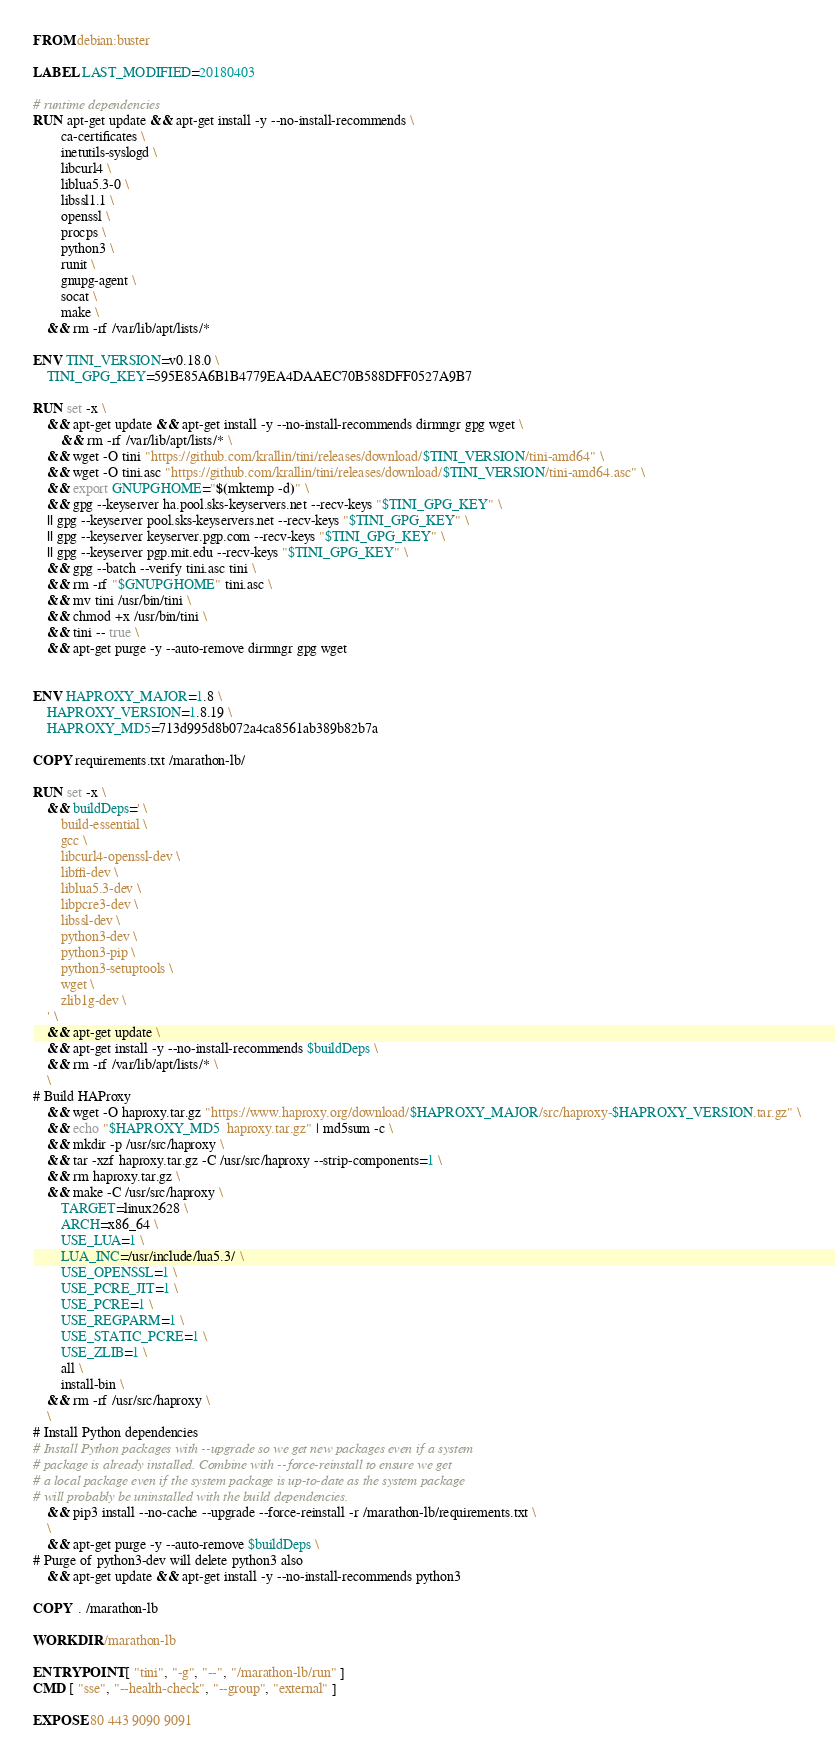Convert code to text. <code><loc_0><loc_0><loc_500><loc_500><_Dockerfile_>FROM debian:buster

LABEL LAST_MODIFIED=20180403

# runtime dependencies
RUN apt-get update && apt-get install -y --no-install-recommends \
        ca-certificates \
        inetutils-syslogd \
        libcurl4 \
        liblua5.3-0 \
        libssl1.1 \
        openssl \
        procps \
        python3 \
        runit \
        gnupg-agent \
        socat \
        make \
    && rm -rf /var/lib/apt/lists/*

ENV TINI_VERSION=v0.18.0 \
    TINI_GPG_KEY=595E85A6B1B4779EA4DAAEC70B588DFF0527A9B7

RUN set -x \
    && apt-get update && apt-get install -y --no-install-recommends dirmngr gpg wget \
        && rm -rf /var/lib/apt/lists/* \
    && wget -O tini "https://github.com/krallin/tini/releases/download/$TINI_VERSION/tini-amd64" \
    && wget -O tini.asc "https://github.com/krallin/tini/releases/download/$TINI_VERSION/tini-amd64.asc" \
    && export GNUPGHOME="$(mktemp -d)" \
    && gpg --keyserver ha.pool.sks-keyservers.net --recv-keys "$TINI_GPG_KEY" \
    || gpg --keyserver pool.sks-keyservers.net --recv-keys "$TINI_GPG_KEY" \
    || gpg --keyserver keyserver.pgp.com --recv-keys "$TINI_GPG_KEY" \
    || gpg --keyserver pgp.mit.edu --recv-keys "$TINI_GPG_KEY" \
    && gpg --batch --verify tini.asc tini \
    && rm -rf "$GNUPGHOME" tini.asc \
    && mv tini /usr/bin/tini \
    && chmod +x /usr/bin/tini \
    && tini -- true \
    && apt-get purge -y --auto-remove dirmngr gpg wget


ENV HAPROXY_MAJOR=1.8 \
    HAPROXY_VERSION=1.8.19 \
    HAPROXY_MD5=713d995d8b072a4ca8561ab389b82b7a

COPY requirements.txt /marathon-lb/

RUN set -x \
    && buildDeps=' \
        build-essential \
        gcc \
        libcurl4-openssl-dev \
        libffi-dev \
        liblua5.3-dev \
        libpcre3-dev \
        libssl-dev \
        python3-dev \
        python3-pip \
        python3-setuptools \
        wget \
        zlib1g-dev \
    ' \
    && apt-get update \
    && apt-get install -y --no-install-recommends $buildDeps \
    && rm -rf /var/lib/apt/lists/* \
    \
# Build HAProxy
    && wget -O haproxy.tar.gz "https://www.haproxy.org/download/$HAPROXY_MAJOR/src/haproxy-$HAPROXY_VERSION.tar.gz" \
    && echo "$HAPROXY_MD5  haproxy.tar.gz" | md5sum -c \
    && mkdir -p /usr/src/haproxy \
    && tar -xzf haproxy.tar.gz -C /usr/src/haproxy --strip-components=1 \
    && rm haproxy.tar.gz \
    && make -C /usr/src/haproxy \
        TARGET=linux2628 \
        ARCH=x86_64 \
        USE_LUA=1 \
        LUA_INC=/usr/include/lua5.3/ \
        USE_OPENSSL=1 \
        USE_PCRE_JIT=1 \
        USE_PCRE=1 \
        USE_REGPARM=1 \
        USE_STATIC_PCRE=1 \
        USE_ZLIB=1 \
        all \
        install-bin \
    && rm -rf /usr/src/haproxy \
    \
# Install Python dependencies
# Install Python packages with --upgrade so we get new packages even if a system
# package is already installed. Combine with --force-reinstall to ensure we get
# a local package even if the system package is up-to-date as the system package
# will probably be uninstalled with the build dependencies.
    && pip3 install --no-cache --upgrade --force-reinstall -r /marathon-lb/requirements.txt \
    \
    && apt-get purge -y --auto-remove $buildDeps \
# Purge of python3-dev will delete python3 also
    && apt-get update && apt-get install -y --no-install-recommends python3

COPY  . /marathon-lb

WORKDIR /marathon-lb

ENTRYPOINT [ "tini", "-g", "--", "/marathon-lb/run" ]
CMD [ "sse", "--health-check", "--group", "external" ]

EXPOSE 80 443 9090 9091
</code> 